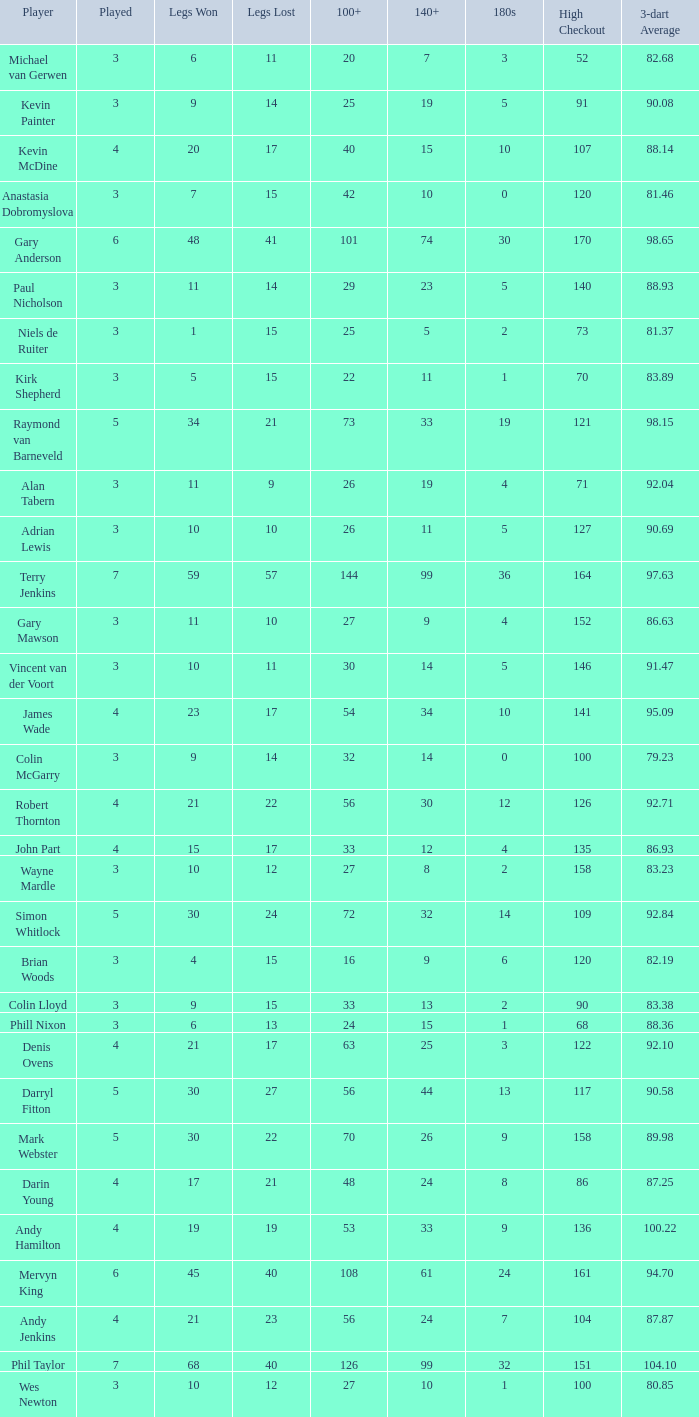What is the lowest high checkout when 140+ is 61, and played is larger than 6? None. 